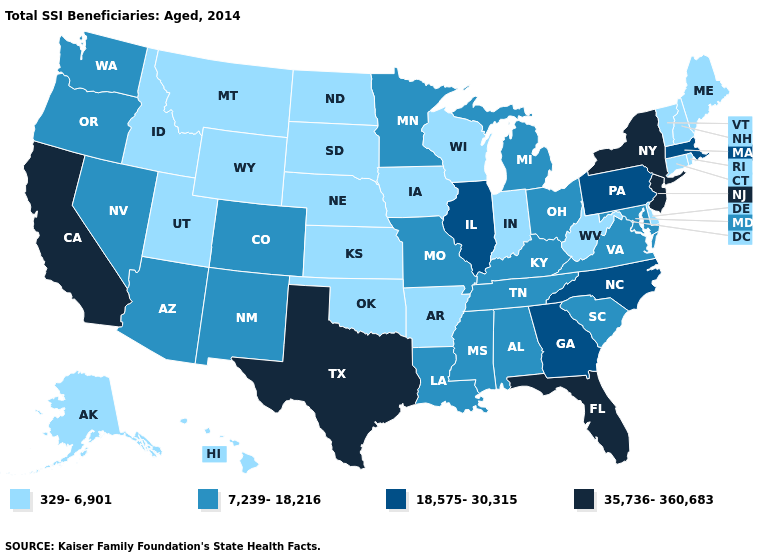Name the states that have a value in the range 329-6,901?
Quick response, please. Alaska, Arkansas, Connecticut, Delaware, Hawaii, Idaho, Indiana, Iowa, Kansas, Maine, Montana, Nebraska, New Hampshire, North Dakota, Oklahoma, Rhode Island, South Dakota, Utah, Vermont, West Virginia, Wisconsin, Wyoming. Name the states that have a value in the range 18,575-30,315?
Short answer required. Georgia, Illinois, Massachusetts, North Carolina, Pennsylvania. Does Hawaii have the same value as Kentucky?
Write a very short answer. No. Name the states that have a value in the range 18,575-30,315?
Quick response, please. Georgia, Illinois, Massachusetts, North Carolina, Pennsylvania. What is the lowest value in states that border Virginia?
Answer briefly. 329-6,901. Name the states that have a value in the range 35,736-360,683?
Keep it brief. California, Florida, New Jersey, New York, Texas. Name the states that have a value in the range 18,575-30,315?
Keep it brief. Georgia, Illinois, Massachusetts, North Carolina, Pennsylvania. Which states have the lowest value in the Northeast?
Concise answer only. Connecticut, Maine, New Hampshire, Rhode Island, Vermont. What is the value of Mississippi?
Short answer required. 7,239-18,216. What is the value of Minnesota?
Quick response, please. 7,239-18,216. Which states hav the highest value in the West?
Be succinct. California. Among the states that border South Carolina , which have the lowest value?
Write a very short answer. Georgia, North Carolina. Does Kansas have a lower value than Nevada?
Write a very short answer. Yes. What is the highest value in the USA?
Give a very brief answer. 35,736-360,683. Name the states that have a value in the range 18,575-30,315?
Be succinct. Georgia, Illinois, Massachusetts, North Carolina, Pennsylvania. 